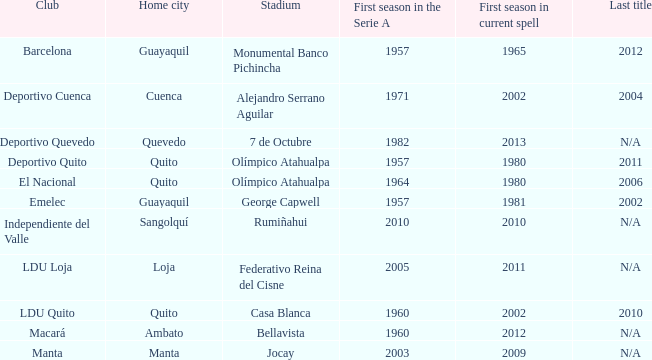Parse the table in full. {'header': ['Club', 'Home city', 'Stadium', 'First season in the Serie A', 'First season in current spell', 'Last title'], 'rows': [['Barcelona', 'Guayaquil', 'Monumental Banco Pichincha', '1957', '1965', '2012'], ['Deportivo Cuenca', 'Cuenca', 'Alejandro Serrano Aguilar', '1971', '2002', '2004'], ['Deportivo Quevedo', 'Quevedo', '7 de Octubre', '1982', '2013', 'N/A'], ['Deportivo Quito', 'Quito', 'Olímpico Atahualpa', '1957', '1980', '2011'], ['El Nacional', 'Quito', 'Olímpico Atahualpa', '1964', '1980', '2006'], ['Emelec', 'Guayaquil', 'George Capwell', '1957', '1981', '2002'], ['Independiente del Valle', 'Sangolquí', 'Rumiñahui', '2010', '2010', 'N/A'], ['LDU Loja', 'Loja', 'Federativo Reina del Cisne', '2005', '2011', 'N/A'], ['LDU Quito', 'Quito', 'Casa Blanca', '1960', '2002', '2010'], ['Macará', 'Ambato', 'Bellavista', '1960', '2012', 'N/A'], ['Manta', 'Manta', 'Jocay', '2003', '2009', 'N/A']]} Identify the most significant first season in serie a for october 7th. 1982.0. 